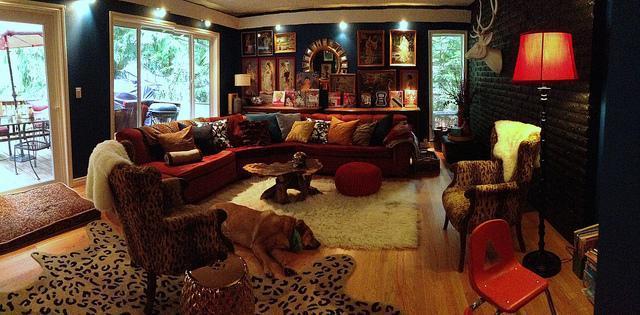How many bookshelves are in this room?
Give a very brief answer. 0. How many chairs are there?
Give a very brief answer. 3. How many couches are visible?
Give a very brief answer. 1. How many donuts in the box?
Give a very brief answer. 0. 